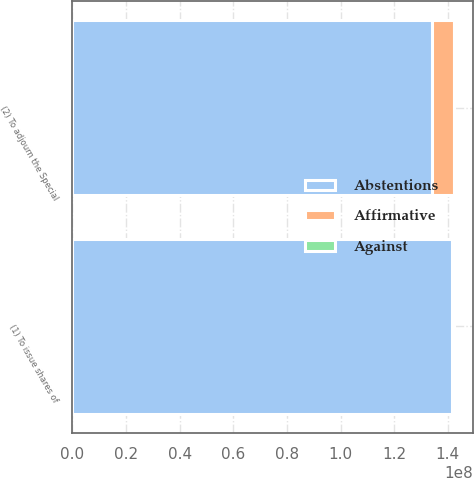<chart> <loc_0><loc_0><loc_500><loc_500><stacked_bar_chart><ecel><fcel>(1) To issue shares of<fcel>(2) To adjourn the Special<nl><fcel>Abstentions<fcel>1.41729e+08<fcel>1.34082e+08<nl><fcel>Affirmative<fcel>297976<fcel>8.06837e+06<nl><fcel>Against<fcel>156165<fcel>32617<nl></chart> 